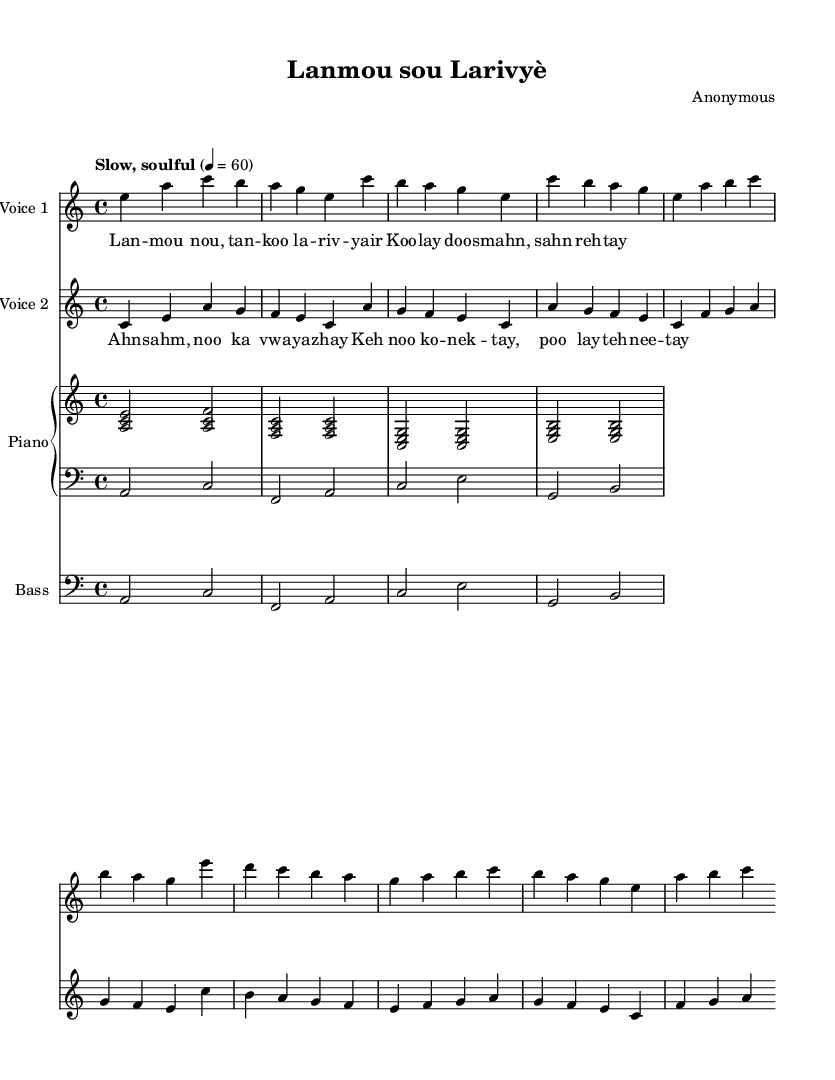What is the key signature of this music? The key signature indicated in the score is A minor, which has no sharps or flats. This can be identified by looking at the key signature at the beginning of the staff before the notes.
Answer: A minor What is the time signature of this piece? The time signature shown in the score is 4/4, which is indicated near the beginning of the staff. To confirm, you look for the fraction that denotes the beats per measure.
Answer: 4/4 What is the tempo marking for this piece? The tempo marking states "Slow, soulful" with a metronome marking of 60 beats per minute, indicating the speed of the piece. This is found at the beginning of the score above the staff lines.
Answer: Slow, soulful How many voices are there in this duet? The score clearly shows there are two voices indicated as "Voice 1" and "Voice 2" at the top of the respective staves. Each voice is labeled differently, confirming there are two distinct vocal parts.
Answer: Two What is the main lyrical theme of the chorus? The chorus lyrics focus on connection and love, as expressed through phrases like "Keh noo ko - nek - tay," which translates to feelings of unity. This can be inferred by reading the chorus lyrics in both the musical notation and understanding their meaning.
Answer: Love and connection Which part plays the bass line? The bass line is indicated at the bottom staff with the label "Bass" and uses bass clef notation. You can identify it as a lower voice part that provides harmonic support to the music.
Answer: Bass 